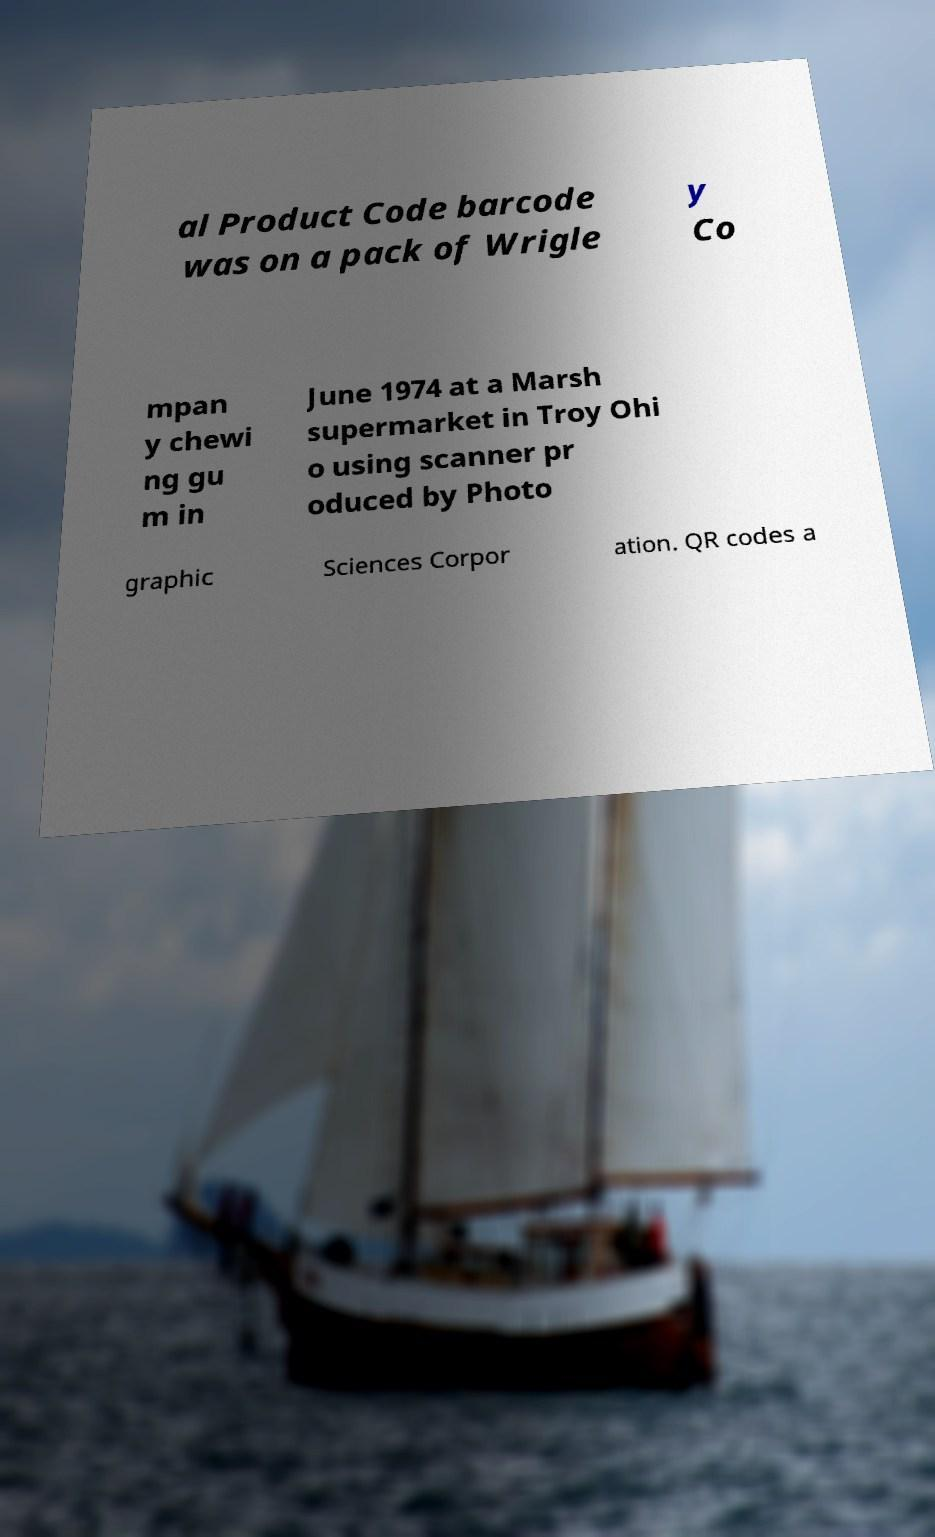Please read and relay the text visible in this image. What does it say? al Product Code barcode was on a pack of Wrigle y Co mpan y chewi ng gu m in June 1974 at a Marsh supermarket in Troy Ohi o using scanner pr oduced by Photo graphic Sciences Corpor ation. QR codes a 